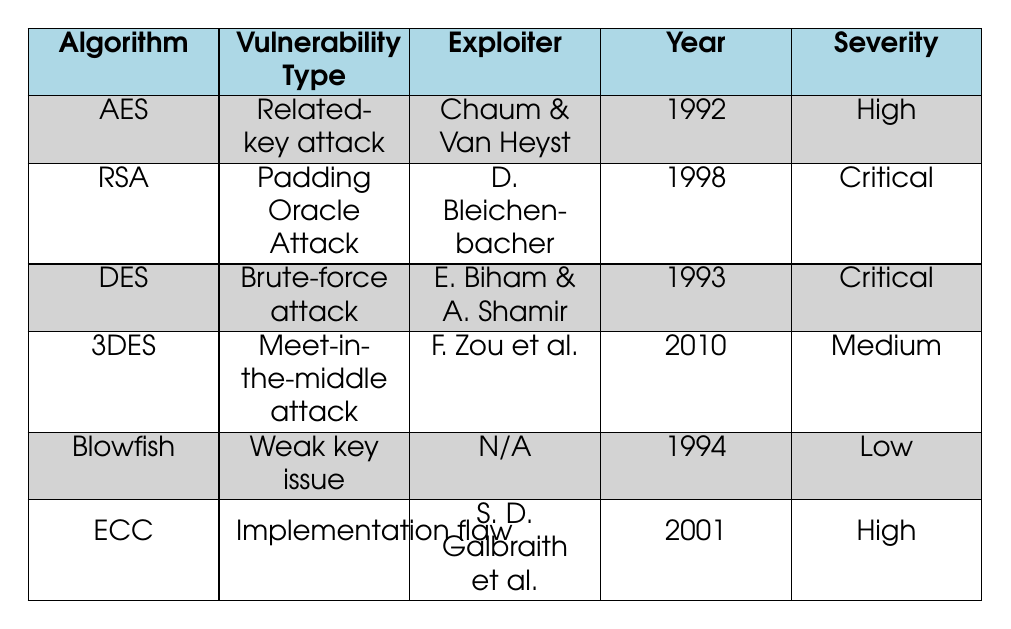What is the vulnerability type for RSA? The table lists RSA under the "Vulnerability Type" column with the value "Padding Oracle Attack."
Answer: Padding Oracle Attack Who exploited the weakness in AES and in what year? Referring to the row corresponding to AES, the exploiter is listed as "Chaum & Van Heyst" and the year as "1992."
Answer: Chaum & Van Heyst, 1992 Is the severity level of DES classified as critical? By checking the row for DES, the severity is stated as "Critical." This confirms that the severity level is indeed critical.
Answer: Yes How many algorithms have a vulnerability classified as "High"? In the table, AES and ECC are listed as having a severity level of "High." Therefore, there are 2 algorithms with this classification.
Answer: 2 Which attacker demonstrated a related-key attack on AES? The table shows that the attack on AES was demonstrated by "Chaum & Van Heyst," making this their associated exploit.
Answer: Chaum & Van Heyst List all the vulnerabilities associated with algorithms that have a "Critical" severity level. Identifying the rows for RSA and DES, we find their vulnerabilities are "Padding Oracle Attack" and "Brute-force attack," respectively.
Answer: Padding Oracle Attack, Brute-force attack Is it true that Blowfish has a reported exploit? The table indicates that Blowfish does have a reported exploit, which is categorized under the "Weak key issue."
Answer: Yes What is the average severity level of all encryption algorithms listed? Analyzing the severity levels (High, Critical, Medium, Low), where we score High=3, Critical=4, Medium=2, and Low=1, the total score becomes 14. There are 6 algorithms (14/6) which gives an average severity score of approximately 2.33, which falls between Medium and High.
Answer: Between Medium and High Which algorithm's vulnerabilities are considered to have a lower threat level, AES or Blowfish? In comparing the severity levels, AES has "High" severity and Blowfish has "Low" severity. Therefore, Blowfish is at a lower threat level than AES.
Answer: Blowfish 